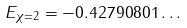Convert formula to latex. <formula><loc_0><loc_0><loc_500><loc_500>E _ { \chi = 2 } = - 0 . 4 2 7 9 0 8 0 1 \dots</formula> 